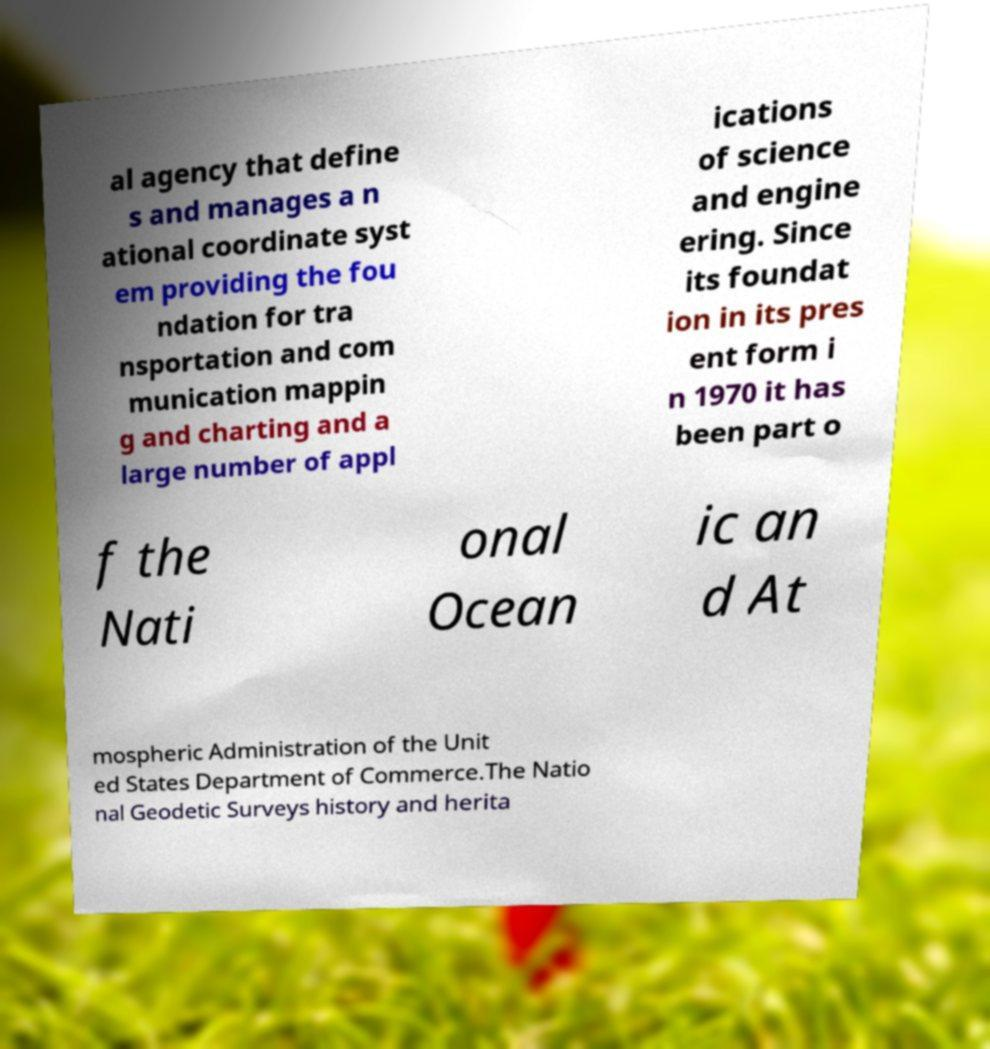What messages or text are displayed in this image? I need them in a readable, typed format. al agency that define s and manages a n ational coordinate syst em providing the fou ndation for tra nsportation and com munication mappin g and charting and a large number of appl ications of science and engine ering. Since its foundat ion in its pres ent form i n 1970 it has been part o f the Nati onal Ocean ic an d At mospheric Administration of the Unit ed States Department of Commerce.The Natio nal Geodetic Surveys history and herita 